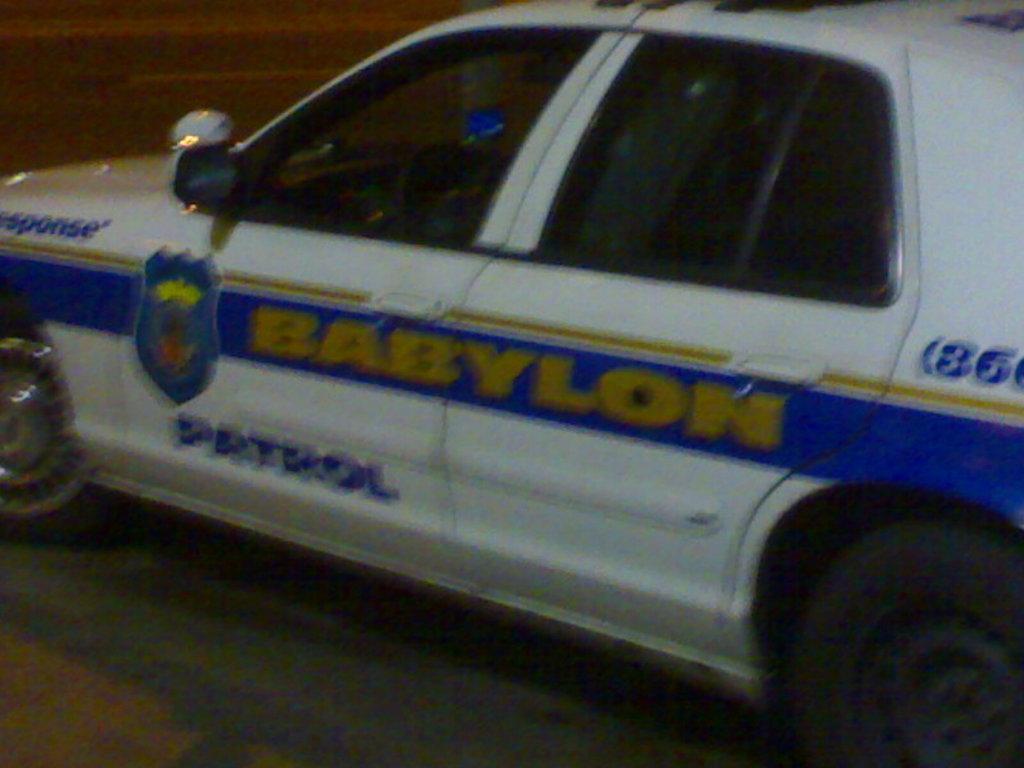What city is this patrol car from?
Your response must be concise. Babylon. Where town does this police car belong to?
Ensure brevity in your answer.  Babylon. 